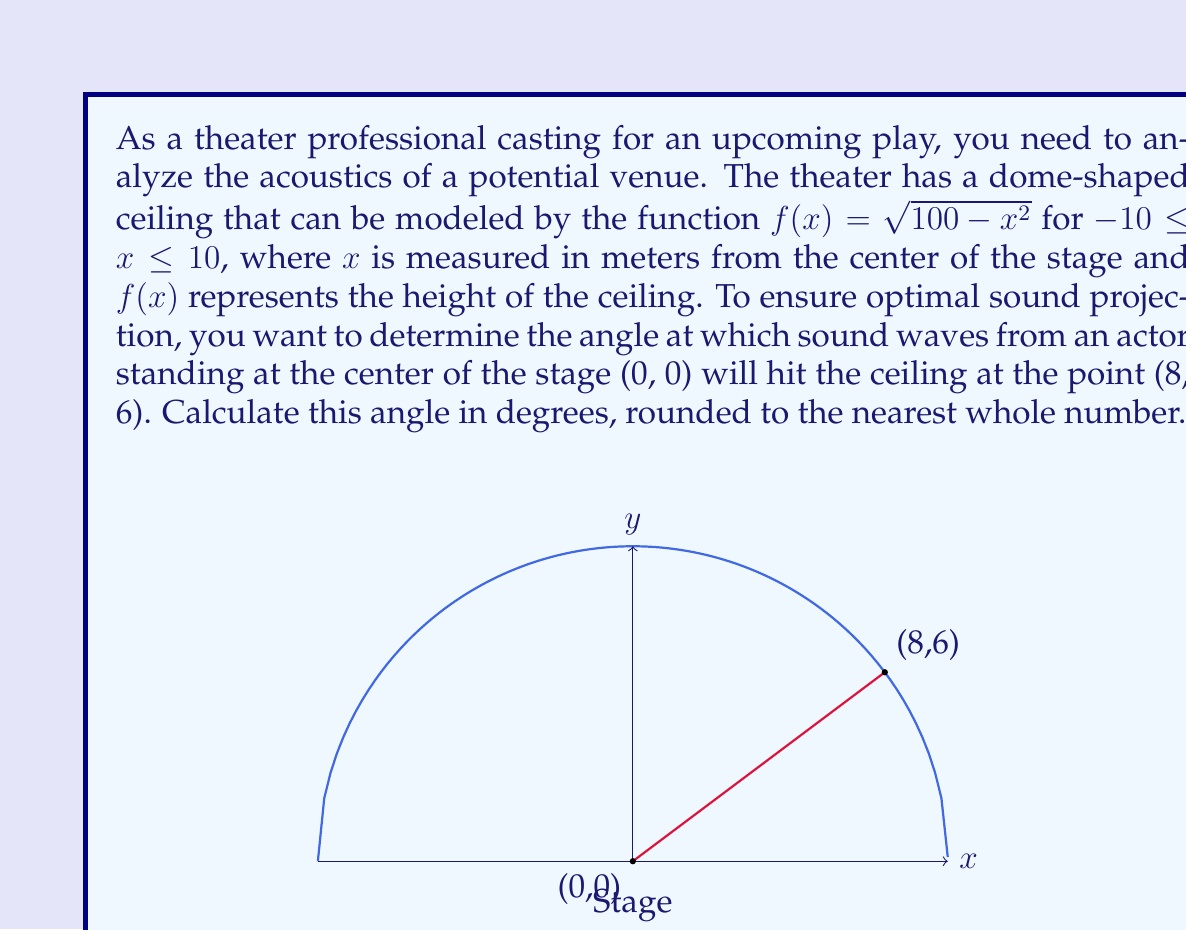Provide a solution to this math problem. To solve this problem, we'll follow these steps:

1) We need to find the angle between the line from (0, 0) to (8, 6) and the horizontal stage floor.

2) We can use the arctangent function to find this angle. The tangent of the angle is the ratio of the vertical distance to the horizontal distance.

3) The horizontal distance is 8 meters (the x-coordinate of the point on the ceiling).

4) The vertical distance is 6 meters (the y-coordinate of the point on the ceiling).

5) Let's call our angle $\theta$. Then:

   $\tan(\theta) = \frac{\text{opposite}}{\text{adjacent}} = \frac{6}{8} = 0.75$

6) To find $\theta$, we take the arctangent of both sides:

   $\theta = \arctan(0.75)$

7) Using a calculator or computer, we can find that:

   $\theta \approx 0.6435$ radians

8) To convert this to degrees, we multiply by $\frac{180}{\pi}$:

   $\theta \approx 0.6435 \cdot \frac{180}{\pi} \approx 36.87$ degrees

9) Rounding to the nearest whole number, we get 37 degrees.
Answer: 37° 